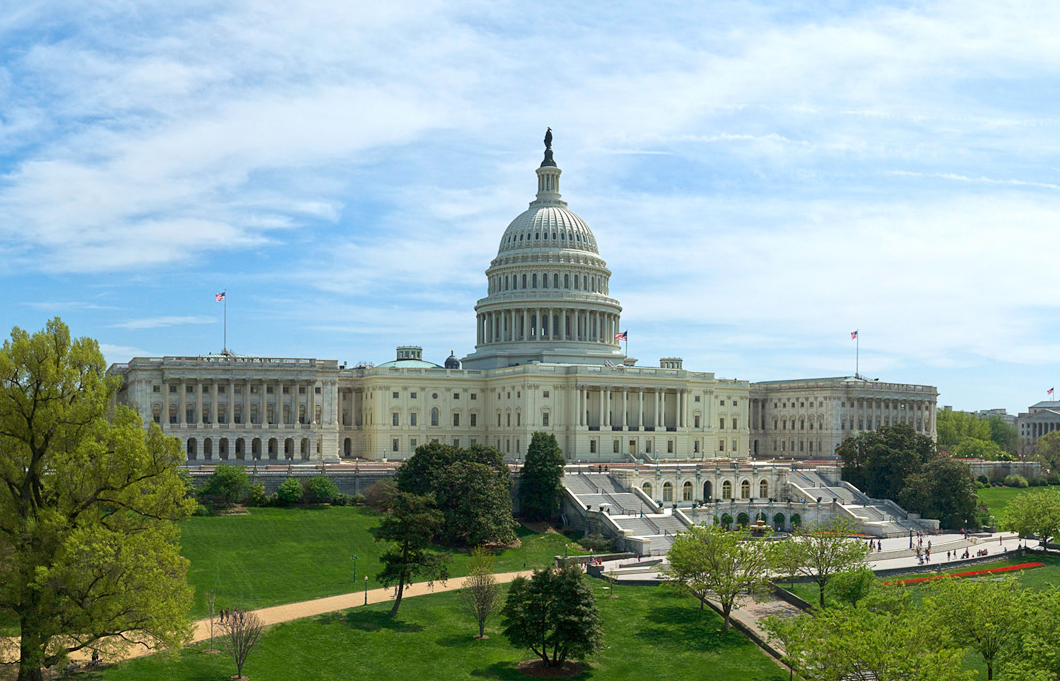What is the historical significance of the United States Capitol? The United States Capitol is not just an architectural marvel but also a symbol of America's democracy. It has housed the legislative branches of the U.S. government since 1800. The building has witnessed major events, including presidential inaugurations, state funerals, and pivotal legislative decisions. It also stood through the War of 1812 when it was burned by the British, symbolizing resilience and continuity of the American government. 